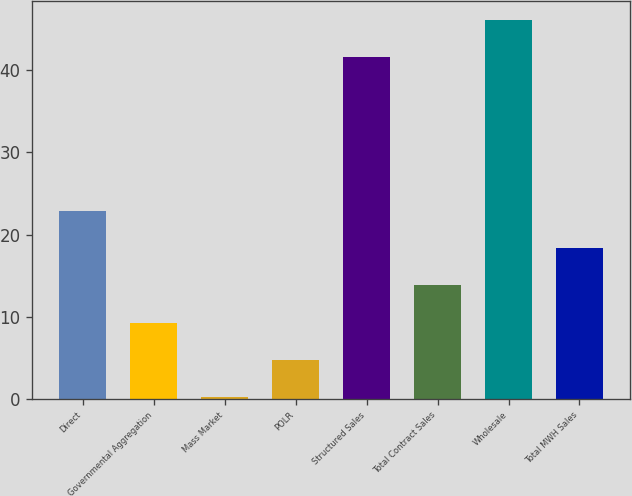Convert chart to OTSL. <chart><loc_0><loc_0><loc_500><loc_500><bar_chart><fcel>Direct<fcel>Governmental Aggregation<fcel>Mass Market<fcel>POLR<fcel>Structured Sales<fcel>Total Contract Sales<fcel>Wholesale<fcel>Total MWH Sales<nl><fcel>22.9<fcel>9.28<fcel>0.2<fcel>4.74<fcel>41.6<fcel>13.82<fcel>46.14<fcel>18.36<nl></chart> 